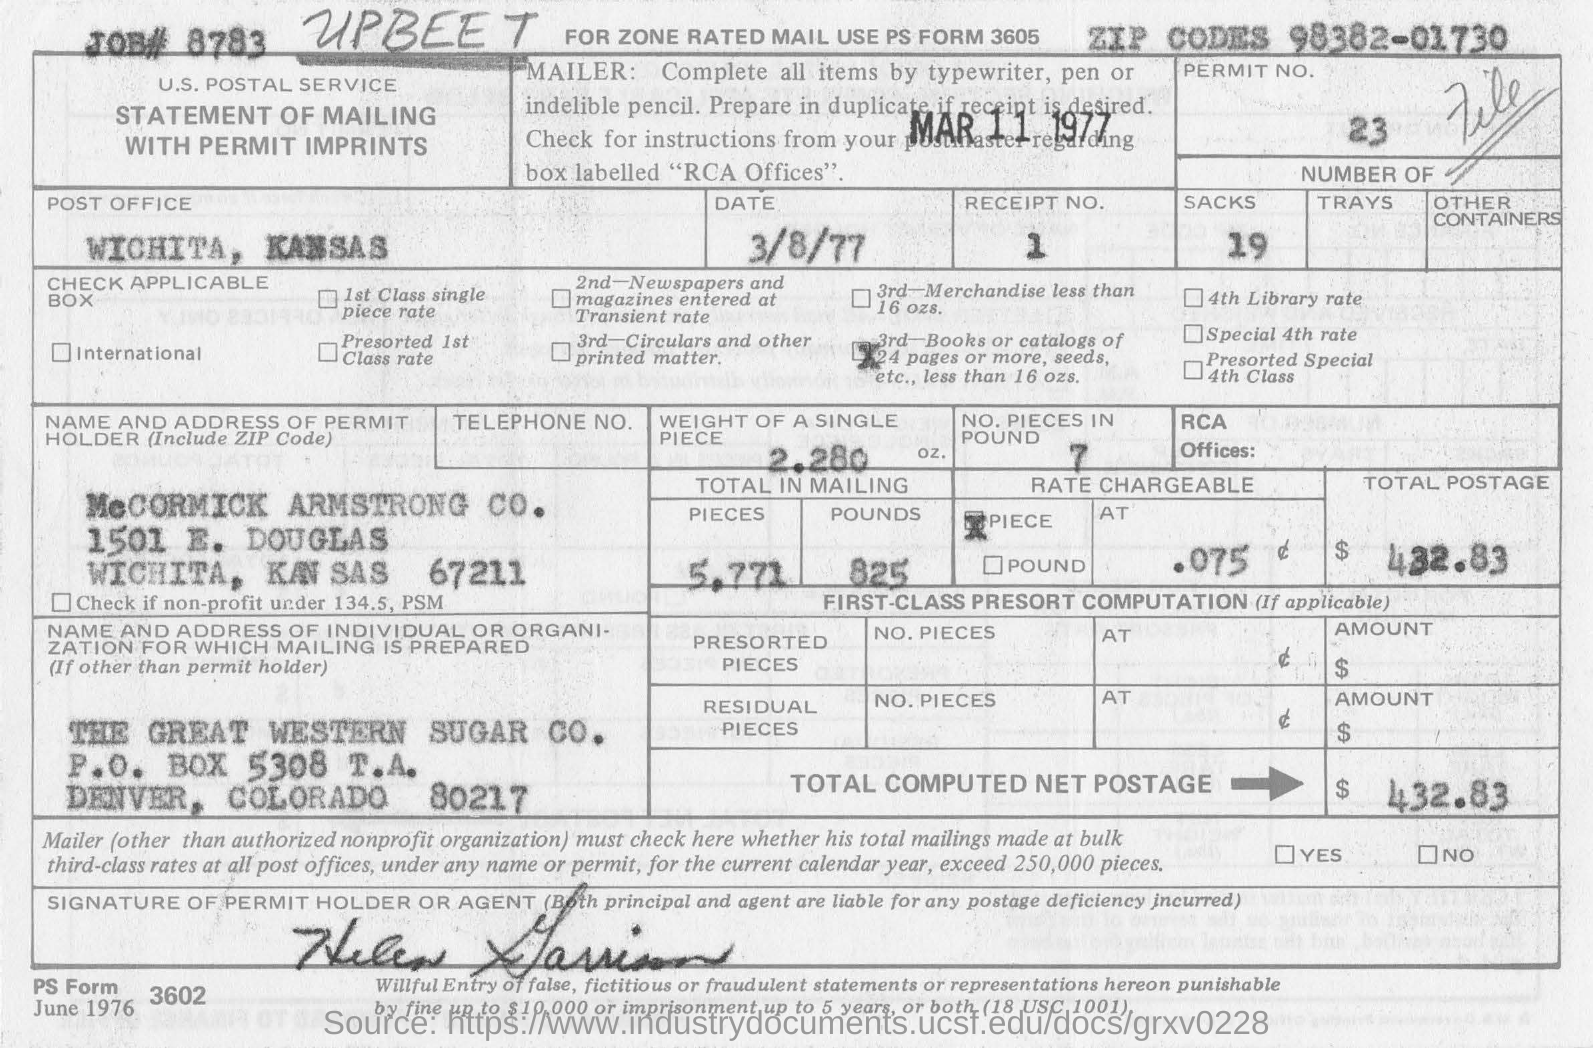Which post office is the form from?
Keep it short and to the point. Wichita, Kansas. What is the total computed net postage?
Give a very brief answer. $ 432.83. What is the job #?
Provide a short and direct response. JOB# 8783. What is the weight of a single piece?
Offer a very short reply. 2.280 oz. What is the permit no.?
Offer a very short reply. 23. What is the name of the permit holder?
Provide a succinct answer. McCormick Armstrong Co. 